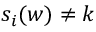Convert formula to latex. <formula><loc_0><loc_0><loc_500><loc_500>s _ { i } ( w ) \neq k</formula> 